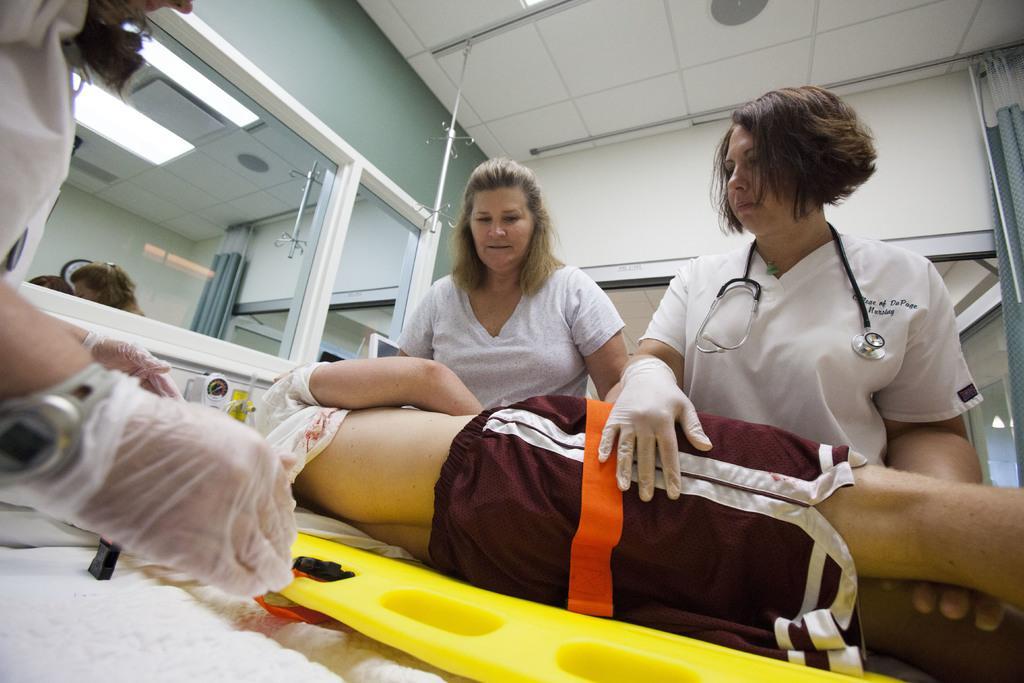Please provide a concise description of this image. In the image we can see there are people wearing clothes, this is a wristwatch, gloves, mirror, light, stethoscope and there is a person lying. 